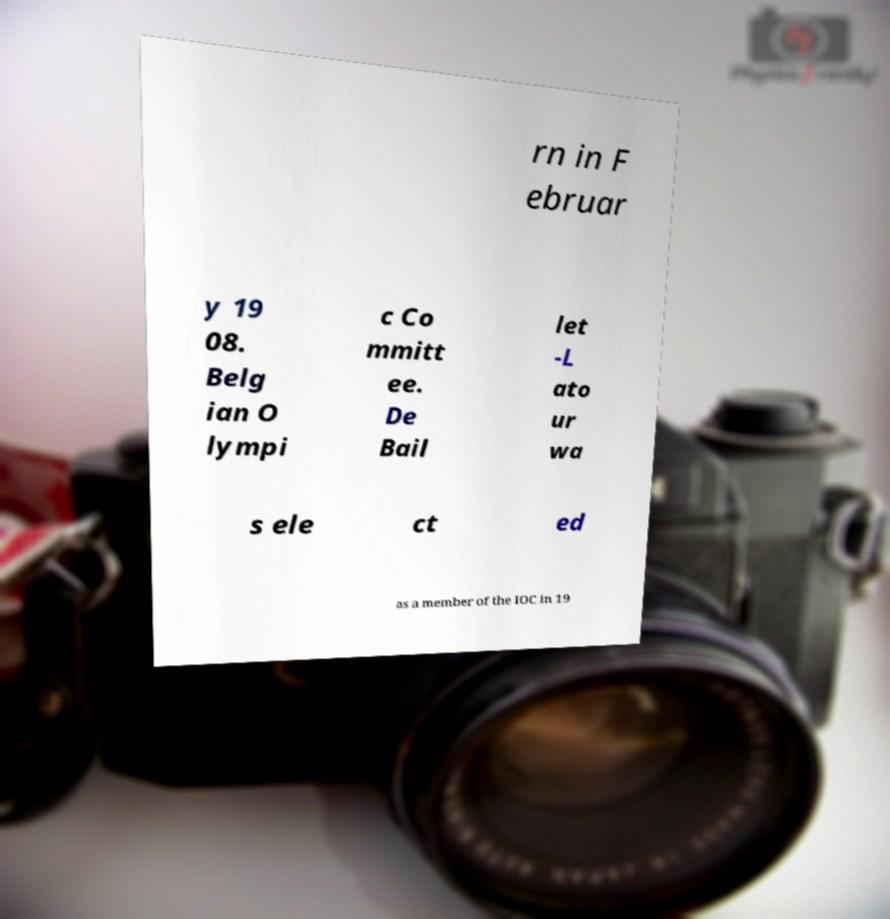Can you read and provide the text displayed in the image?This photo seems to have some interesting text. Can you extract and type it out for me? rn in F ebruar y 19 08. Belg ian O lympi c Co mmitt ee. De Bail let -L ato ur wa s ele ct ed as a member of the IOC in 19 